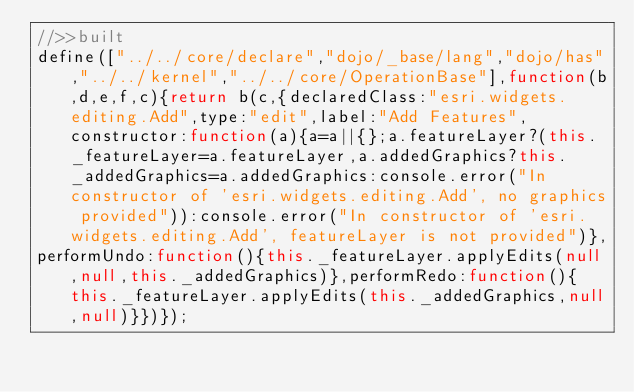<code> <loc_0><loc_0><loc_500><loc_500><_JavaScript_>//>>built
define(["../../core/declare","dojo/_base/lang","dojo/has","../../kernel","../../core/OperationBase"],function(b,d,e,f,c){return b(c,{declaredClass:"esri.widgets.editing.Add",type:"edit",label:"Add Features",constructor:function(a){a=a||{};a.featureLayer?(this._featureLayer=a.featureLayer,a.addedGraphics?this._addedGraphics=a.addedGraphics:console.error("In constructor of 'esri.widgets.editing.Add', no graphics provided")):console.error("In constructor of 'esri.widgets.editing.Add', featureLayer is not provided")},
performUndo:function(){this._featureLayer.applyEdits(null,null,this._addedGraphics)},performRedo:function(){this._featureLayer.applyEdits(this._addedGraphics,null,null)}})});</code> 